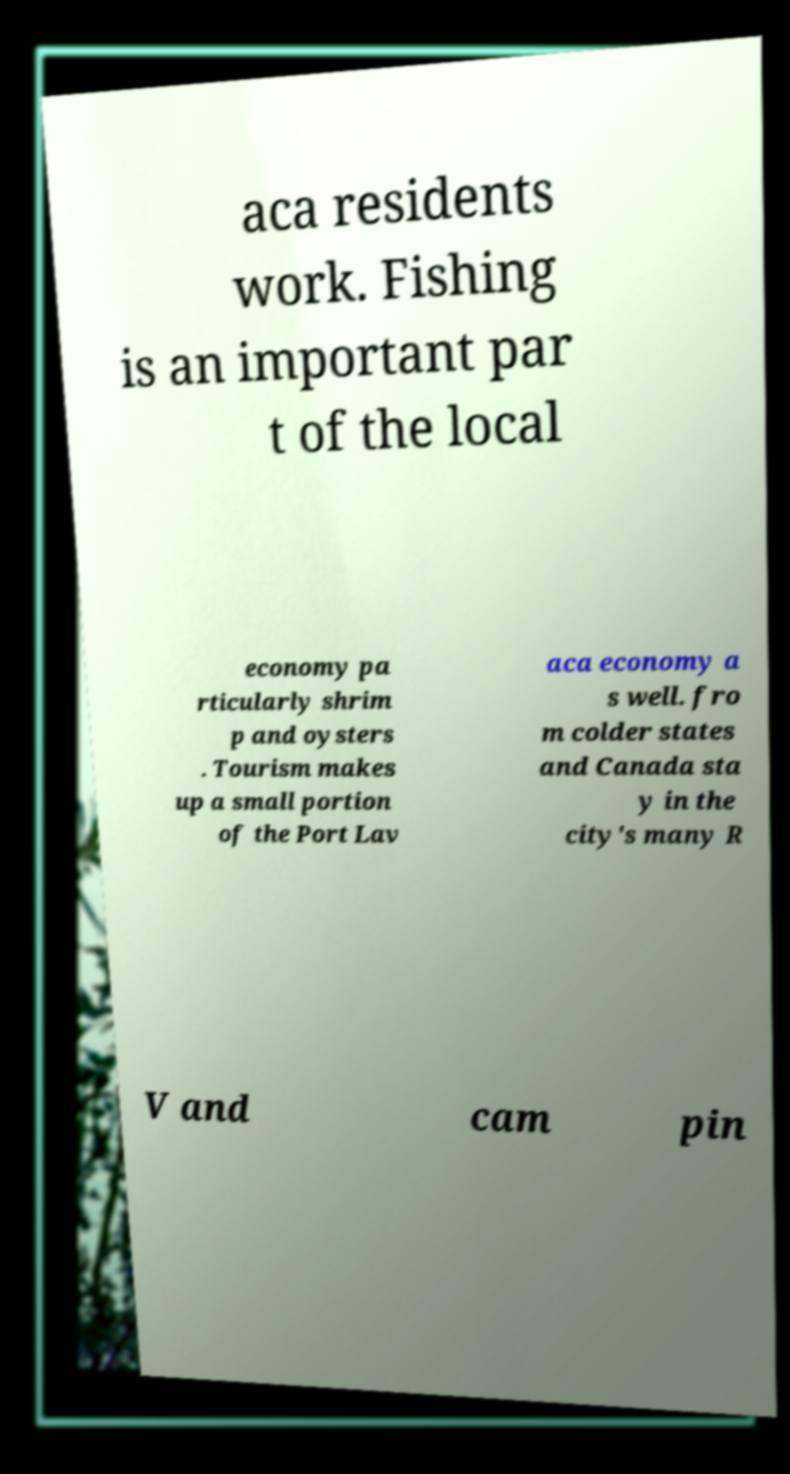There's text embedded in this image that I need extracted. Can you transcribe it verbatim? aca residents work. Fishing is an important par t of the local economy pa rticularly shrim p and oysters . Tourism makes up a small portion of the Port Lav aca economy a s well. fro m colder states and Canada sta y in the city's many R V and cam pin 